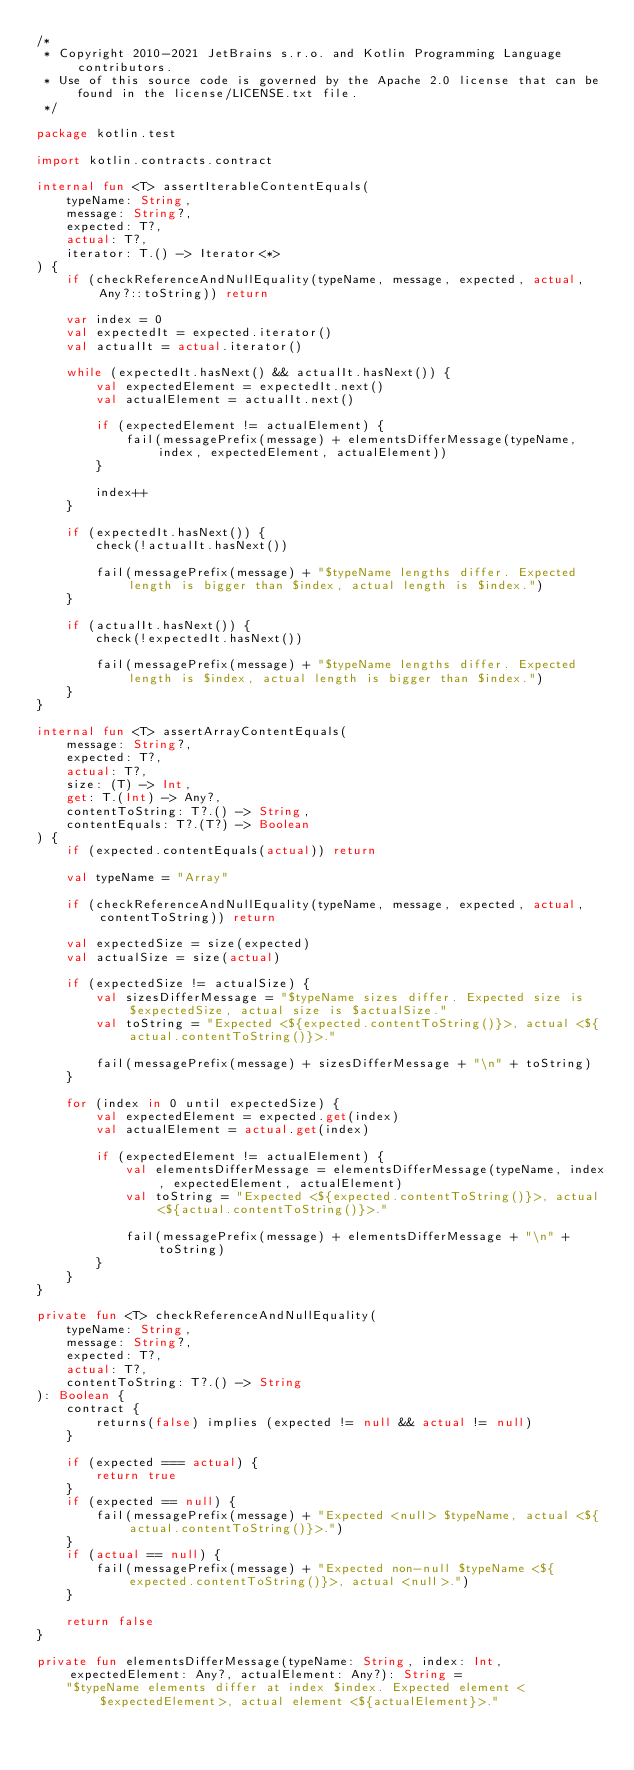<code> <loc_0><loc_0><loc_500><loc_500><_Kotlin_>/*
 * Copyright 2010-2021 JetBrains s.r.o. and Kotlin Programming Language contributors.
 * Use of this source code is governed by the Apache 2.0 license that can be found in the license/LICENSE.txt file.
 */

package kotlin.test

import kotlin.contracts.contract

internal fun <T> assertIterableContentEquals(
    typeName: String,
    message: String?,
    expected: T?,
    actual: T?,
    iterator: T.() -> Iterator<*>
) {
    if (checkReferenceAndNullEquality(typeName, message, expected, actual, Any?::toString)) return

    var index = 0
    val expectedIt = expected.iterator()
    val actualIt = actual.iterator()

    while (expectedIt.hasNext() && actualIt.hasNext()) {
        val expectedElement = expectedIt.next()
        val actualElement = actualIt.next()

        if (expectedElement != actualElement) {
            fail(messagePrefix(message) + elementsDifferMessage(typeName, index, expectedElement, actualElement))
        }

        index++
    }

    if (expectedIt.hasNext()) {
        check(!actualIt.hasNext())

        fail(messagePrefix(message) + "$typeName lengths differ. Expected length is bigger than $index, actual length is $index.")
    }

    if (actualIt.hasNext()) {
        check(!expectedIt.hasNext())

        fail(messagePrefix(message) + "$typeName lengths differ. Expected length is $index, actual length is bigger than $index.")
    }
}

internal fun <T> assertArrayContentEquals(
    message: String?,
    expected: T?,
    actual: T?,
    size: (T) -> Int,
    get: T.(Int) -> Any?,
    contentToString: T?.() -> String,
    contentEquals: T?.(T?) -> Boolean
) {
    if (expected.contentEquals(actual)) return

    val typeName = "Array"

    if (checkReferenceAndNullEquality(typeName, message, expected, actual, contentToString)) return

    val expectedSize = size(expected)
    val actualSize = size(actual)

    if (expectedSize != actualSize) {
        val sizesDifferMessage = "$typeName sizes differ. Expected size is $expectedSize, actual size is $actualSize."
        val toString = "Expected <${expected.contentToString()}>, actual <${actual.contentToString()}>."

        fail(messagePrefix(message) + sizesDifferMessage + "\n" + toString)
    }

    for (index in 0 until expectedSize) {
        val expectedElement = expected.get(index)
        val actualElement = actual.get(index)

        if (expectedElement != actualElement) {
            val elementsDifferMessage = elementsDifferMessage(typeName, index, expectedElement, actualElement)
            val toString = "Expected <${expected.contentToString()}>, actual <${actual.contentToString()}>."

            fail(messagePrefix(message) + elementsDifferMessage + "\n" + toString)
        }
    }
}

private fun <T> checkReferenceAndNullEquality(
    typeName: String,
    message: String?,
    expected: T?,
    actual: T?,
    contentToString: T?.() -> String
): Boolean {
    contract {
        returns(false) implies (expected != null && actual != null)
    }

    if (expected === actual) {
        return true
    }
    if (expected == null) {
        fail(messagePrefix(message) + "Expected <null> $typeName, actual <${actual.contentToString()}>.")
    }
    if (actual == null) {
        fail(messagePrefix(message) + "Expected non-null $typeName <${expected.contentToString()}>, actual <null>.")
    }

    return false
}

private fun elementsDifferMessage(typeName: String, index: Int, expectedElement: Any?, actualElement: Any?): String =
    "$typeName elements differ at index $index. Expected element <$expectedElement>, actual element <${actualElement}>."</code> 